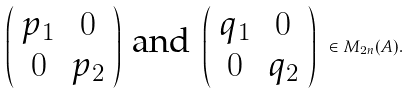<formula> <loc_0><loc_0><loc_500><loc_500>\left ( \begin{array} { c c } p _ { 1 } & 0 \\ 0 & p _ { 2 } \end{array} \right ) \text { and } \left ( \begin{array} { c c } q _ { 1 } & 0 \\ 0 & q _ { 2 } \end{array} \right ) \ \in M _ { 2 n } ( A ) .</formula> 